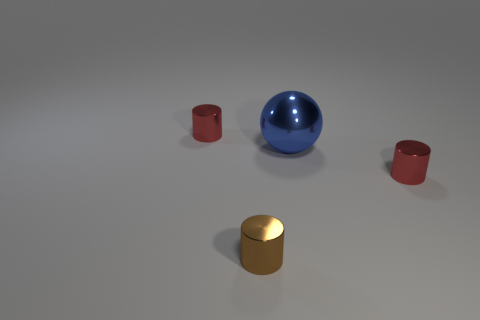Add 3 large blue things. How many objects exist? 7 Subtract all cylinders. How many objects are left? 1 Add 3 large metallic spheres. How many large metallic spheres exist? 4 Subtract 0 yellow balls. How many objects are left? 4 Subtract all small shiny cylinders. Subtract all purple metal things. How many objects are left? 1 Add 3 red metal cylinders. How many red metal cylinders are left? 5 